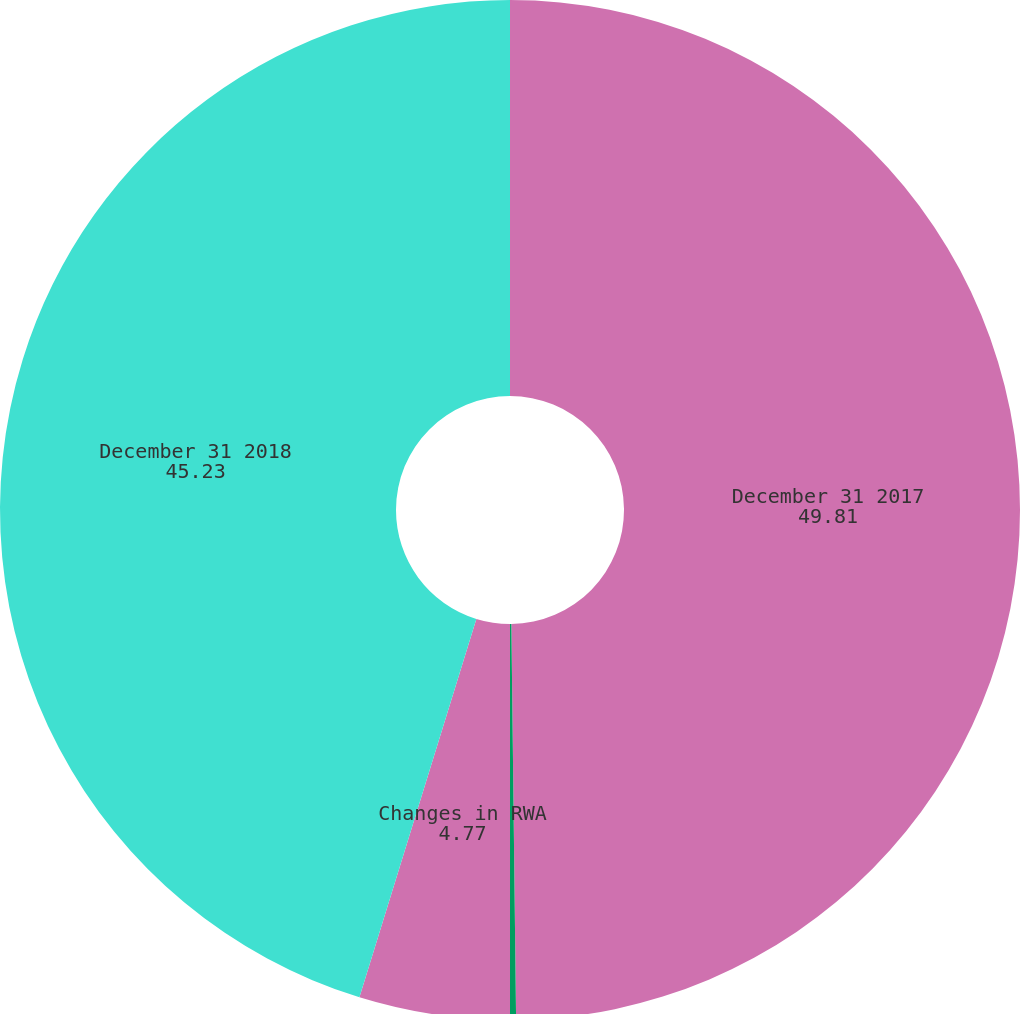Convert chart. <chart><loc_0><loc_0><loc_500><loc_500><pie_chart><fcel>December 31 2017<fcel>Movement in portfolio levels<fcel>Changes in RWA<fcel>December 31 2018<nl><fcel>49.81%<fcel>0.19%<fcel>4.77%<fcel>45.23%<nl></chart> 